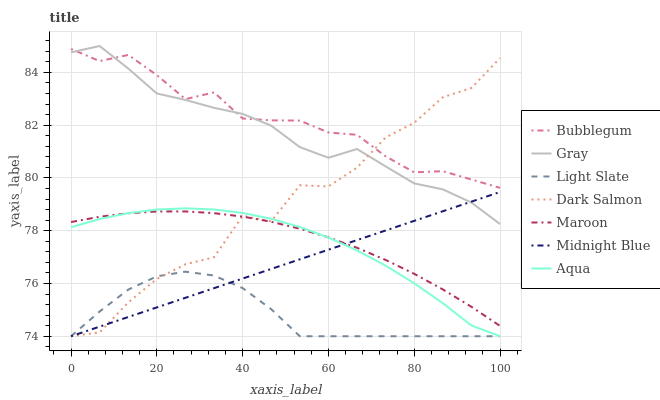Does Light Slate have the minimum area under the curve?
Answer yes or no. Yes. Does Bubblegum have the maximum area under the curve?
Answer yes or no. Yes. Does Midnight Blue have the minimum area under the curve?
Answer yes or no. No. Does Midnight Blue have the maximum area under the curve?
Answer yes or no. No. Is Midnight Blue the smoothest?
Answer yes or no. Yes. Is Dark Salmon the roughest?
Answer yes or no. Yes. Is Light Slate the smoothest?
Answer yes or no. No. Is Light Slate the roughest?
Answer yes or no. No. Does Midnight Blue have the lowest value?
Answer yes or no. Yes. Does Maroon have the lowest value?
Answer yes or no. No. Does Gray have the highest value?
Answer yes or no. Yes. Does Midnight Blue have the highest value?
Answer yes or no. No. Is Light Slate less than Bubblegum?
Answer yes or no. Yes. Is Bubblegum greater than Light Slate?
Answer yes or no. Yes. Does Gray intersect Midnight Blue?
Answer yes or no. Yes. Is Gray less than Midnight Blue?
Answer yes or no. No. Is Gray greater than Midnight Blue?
Answer yes or no. No. Does Light Slate intersect Bubblegum?
Answer yes or no. No. 